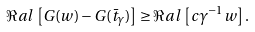<formula> <loc_0><loc_0><loc_500><loc_500>\Re a l \, \left [ G ( w ) - G ( \bar { t } _ { \gamma } ) \right ] \geq \Re a l \, \left [ c \gamma ^ { - 1 } w \right ] .</formula> 